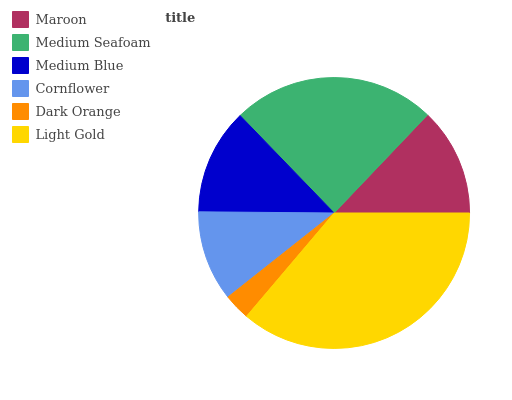Is Dark Orange the minimum?
Answer yes or no. Yes. Is Light Gold the maximum?
Answer yes or no. Yes. Is Medium Seafoam the minimum?
Answer yes or no. No. Is Medium Seafoam the maximum?
Answer yes or no. No. Is Medium Seafoam greater than Maroon?
Answer yes or no. Yes. Is Maroon less than Medium Seafoam?
Answer yes or no. Yes. Is Maroon greater than Medium Seafoam?
Answer yes or no. No. Is Medium Seafoam less than Maroon?
Answer yes or no. No. Is Maroon the high median?
Answer yes or no. Yes. Is Medium Blue the low median?
Answer yes or no. Yes. Is Light Gold the high median?
Answer yes or no. No. Is Medium Seafoam the low median?
Answer yes or no. No. 